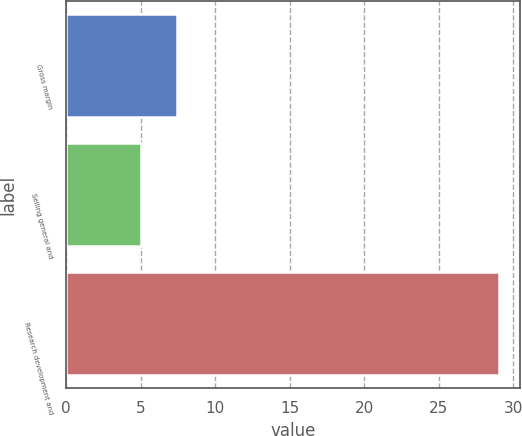Convert chart. <chart><loc_0><loc_0><loc_500><loc_500><bar_chart><fcel>Gross margin<fcel>Selling general and<fcel>Research development and<nl><fcel>7.4<fcel>5<fcel>29<nl></chart> 